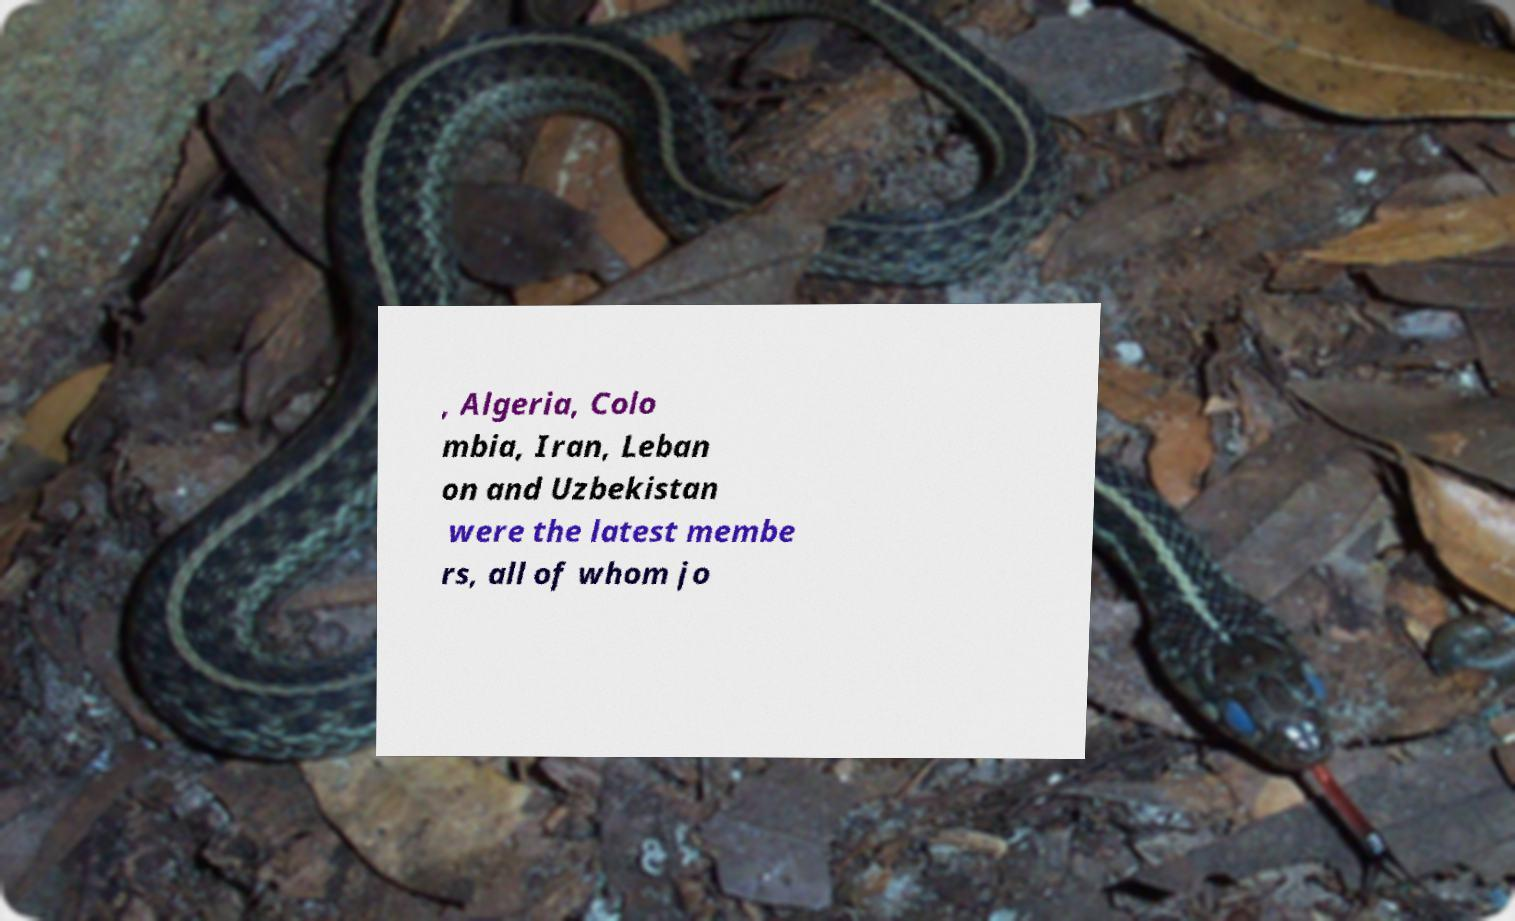Can you accurately transcribe the text from the provided image for me? , Algeria, Colo mbia, Iran, Leban on and Uzbekistan were the latest membe rs, all of whom jo 